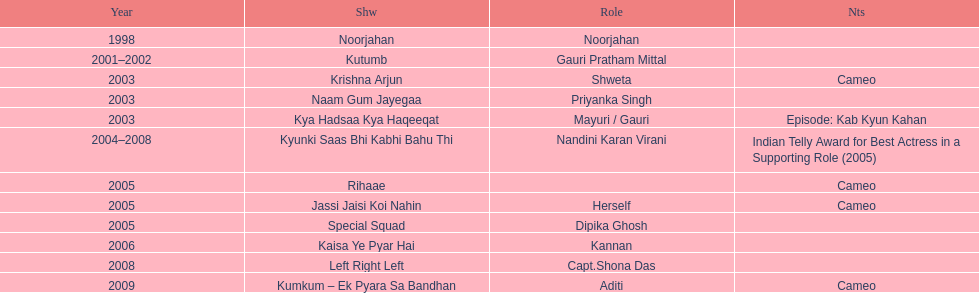The show above left right left Kaisa Ye Pyar Hai. 